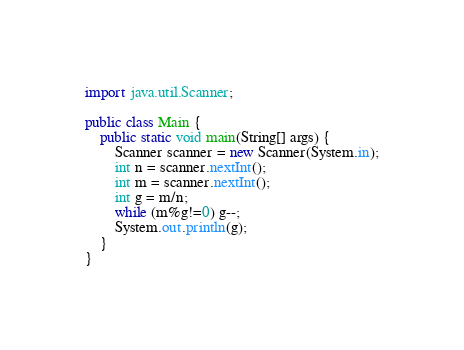Convert code to text. <code><loc_0><loc_0><loc_500><loc_500><_Java_>import java.util.Scanner;

public class Main {
	public static void main(String[] args) {
		Scanner scanner = new Scanner(System.in);
		int n = scanner.nextInt();
		int m = scanner.nextInt();
		int g = m/n;
		while (m%g!=0) g--;
		System.out.println(g);
	}
}</code> 